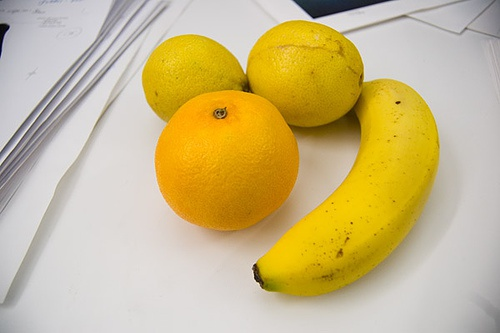Describe the objects in this image and their specific colors. I can see banana in gray, gold, and olive tones, orange in gray and orange tones, orange in gray, gold, and olive tones, and orange in gray, gold, and olive tones in this image. 